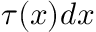Convert formula to latex. <formula><loc_0><loc_0><loc_500><loc_500>\tau ( x ) d x</formula> 